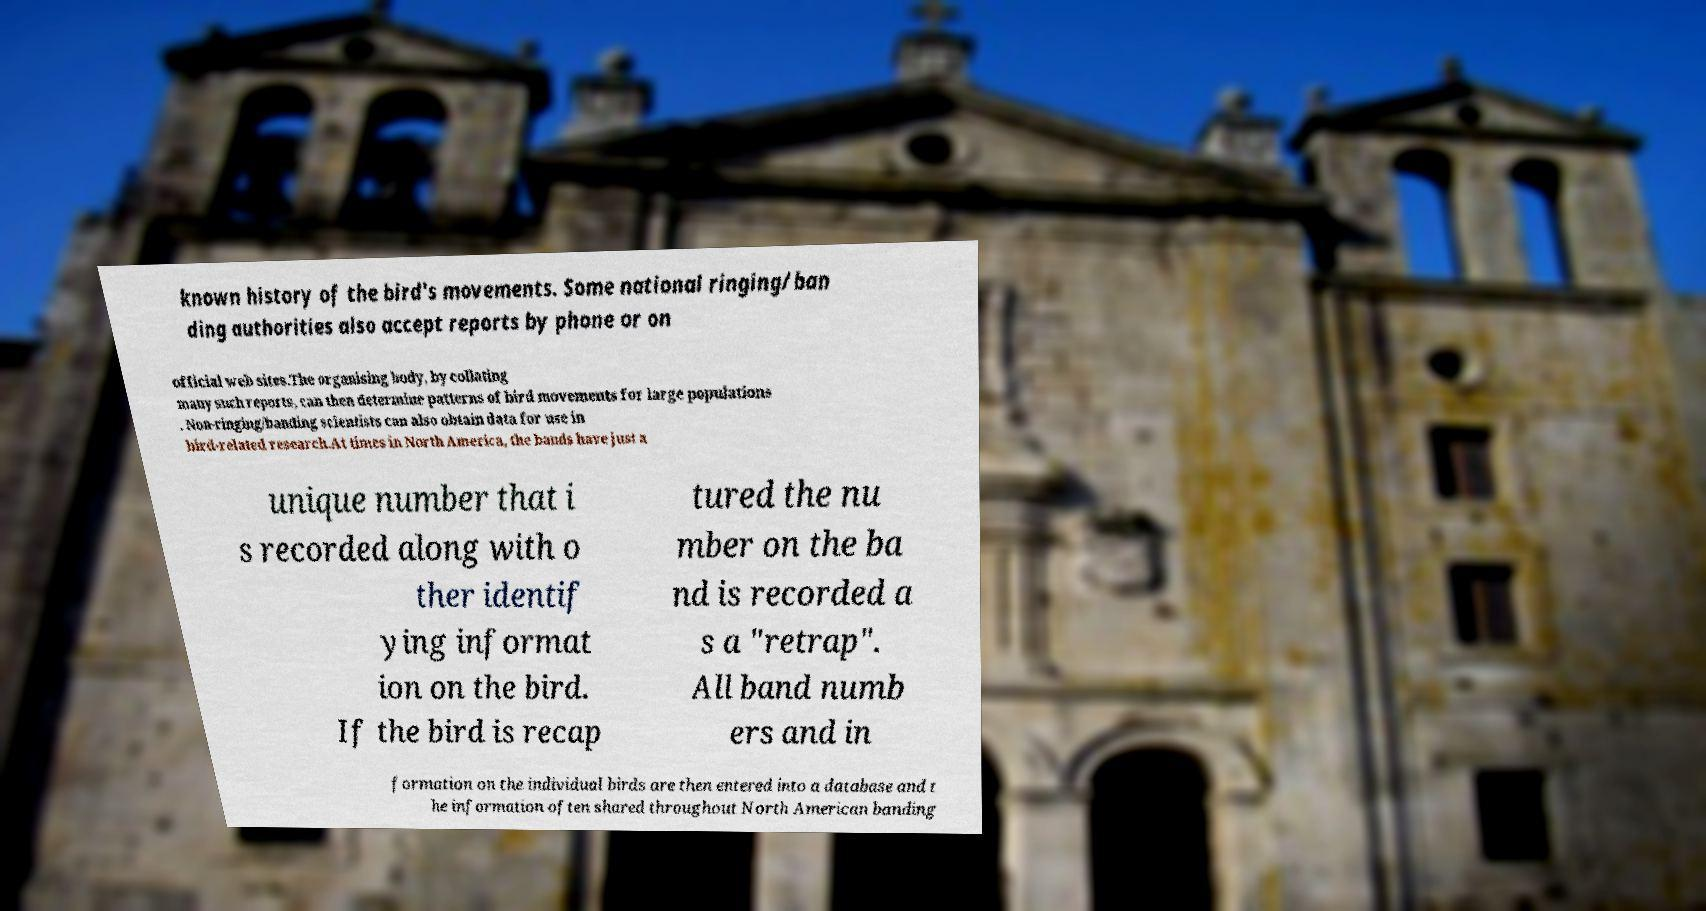Please read and relay the text visible in this image. What does it say? known history of the bird's movements. Some national ringing/ban ding authorities also accept reports by phone or on official web sites.The organising body, by collating many such reports, can then determine patterns of bird movements for large populations . Non-ringing/banding scientists can also obtain data for use in bird-related research.At times in North America, the bands have just a unique number that i s recorded along with o ther identif ying informat ion on the bird. If the bird is recap tured the nu mber on the ba nd is recorded a s a "retrap". All band numb ers and in formation on the individual birds are then entered into a database and t he information often shared throughout North American banding 